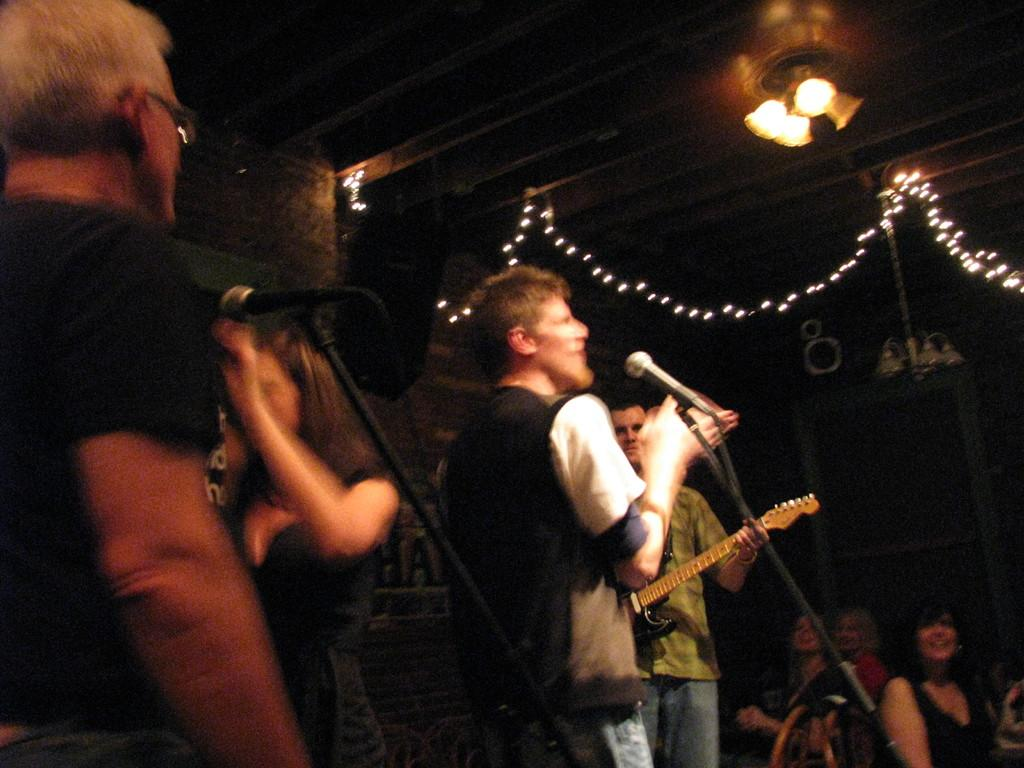How many people can be seen in the image? There are persons standing in the image. What is one person holding in the image? One person is holding a guitar. What equipment is present for amplifying sound in the image? There are microphones with stands in the image. Who is present in the image besides the performers? There are audience members in the image. What can be seen at the top of the image? There are lights visible at the top of the image. What is visible in the background of the image? There is a wall in the background of the image. How many pigs can be seen in the image? There are no pigs present in the image. What type of shop is visible in the image? There is no shop present in the image. 